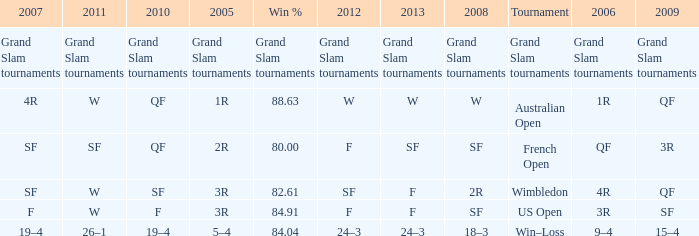What in 2007 has a 2008 of sf, and a 2010 of f? F. 